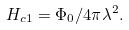Convert formula to latex. <formula><loc_0><loc_0><loc_500><loc_500>H _ { c 1 } = \Phi _ { 0 } / 4 \pi \lambda ^ { 2 } .</formula> 